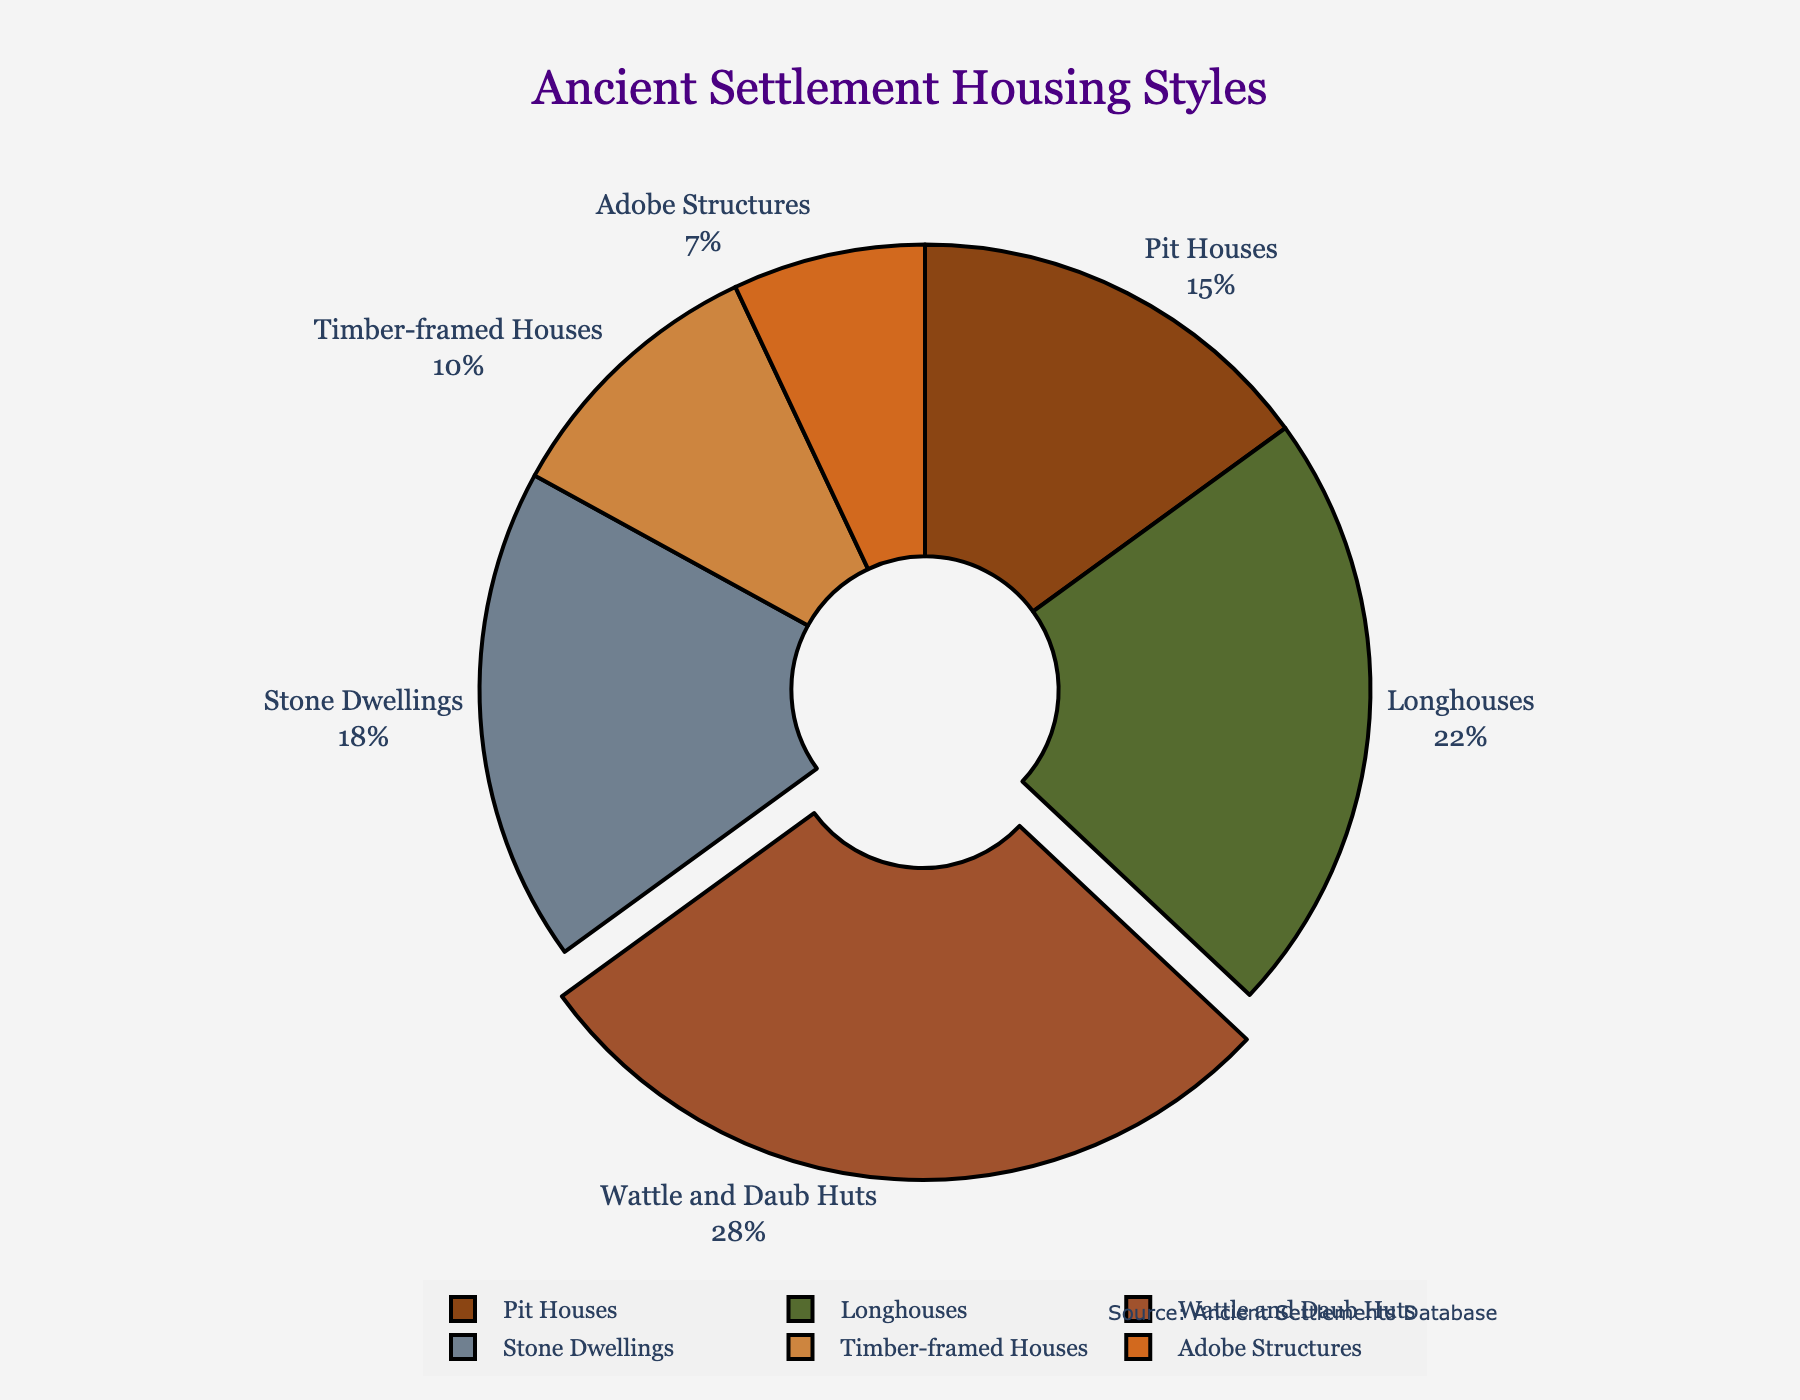Which housing style has the highest proportion in ancient settlements? The pie chart shows the proportions of different housing styles, and the segment with the largest size corresponds to Wattle and Daub Huts. The chart also highlights this segment by pulling it slightly out.
Answer: Wattle and Daub Huts What is the combined proportion of Pit Houses and Timber-framed Houses? The percentage of Pit Houses is 15% and Timber-framed Houses is 10%. Adding these together gives 15% + 10% = 25%.
Answer: 25% Which has a greater proportion, Stone Dwellings or Adobe Structures? The pie chart indicates that Stone Dwellings is 18% and Adobe Structures is 7%. Comparing these, 18% is greater than 7%.
Answer: Stone Dwellings By what percentage does the proportion of Longhouses exceed that of Adobe Structures? The proportion of Longhouses is 22% and that of Adobe Structures is 7%. The difference is 22% - 7% = 15%.
Answer: 15% What is the visual feature used to highlight the housing style with the highest proportion? The pie chart uses a pull-out effect to highlight the segment with the highest proportion, which is Wattle and Daub Huts.
Answer: Pull-out effect Are there more Stone Dwellings or Pit Houses in the ancient settlements according to the chart? The proportion of Stone Dwellings is 18%, while Pit Houses are 15%. Since 18% is greater than 15%, there are more Stone Dwellings.
Answer: Stone Dwellings What is the combined proportion of Longhouses and Stone Dwellings? The percentage for Longhouses is 22% and for Stone Dwellings is 18%. Adding them gives 22% + 18% = 40%.
Answer: 40% Which housing style has the smallest proportion in the pie chart? The pie chart labels show Adobe Structures with the smallest portion of 7%.
Answer: Adobe Structures How much more proportion do Wattle and Daub Huts have compared to Pit Houses? The proportion for Wattle and Daub Huts is 28%, and for Pit Houses it is 15%. The difference is 28% - 15% = 13%.
Answer: 13% 